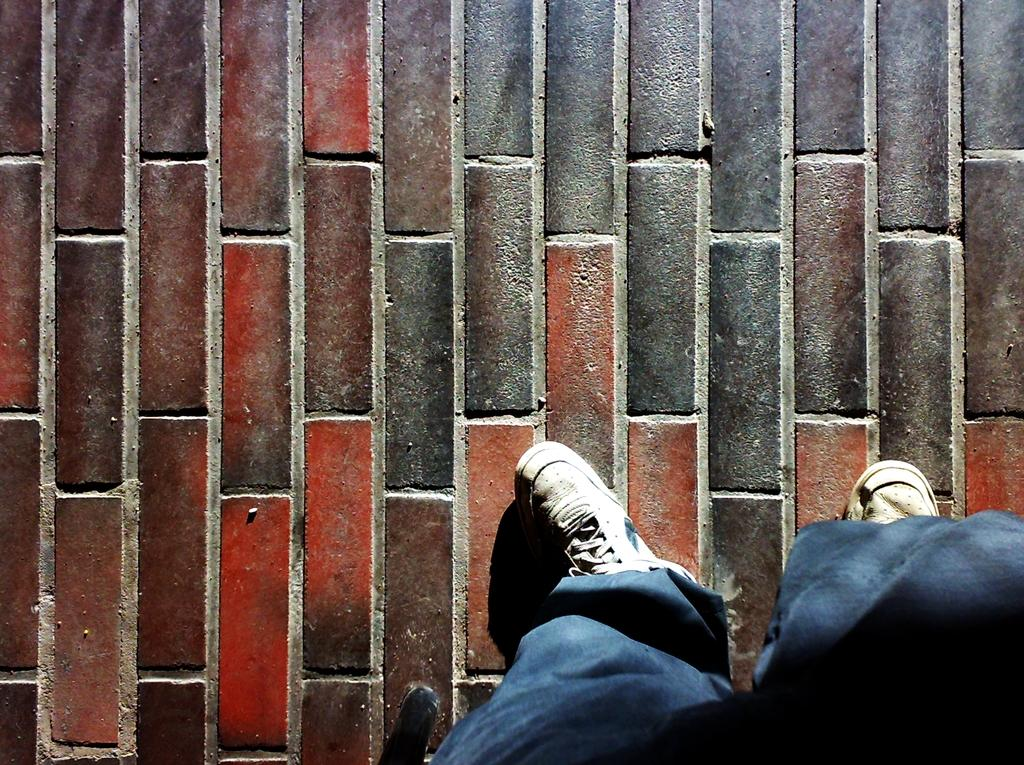What type of flooring is present in the image? There is a brick floor in the floor in the image. What part of a person can be seen in the image? Human legs are visible in the image. What type of bread is being recited in the image? There is no bread or verse present in the image; it only features a brick floor and human legs. 